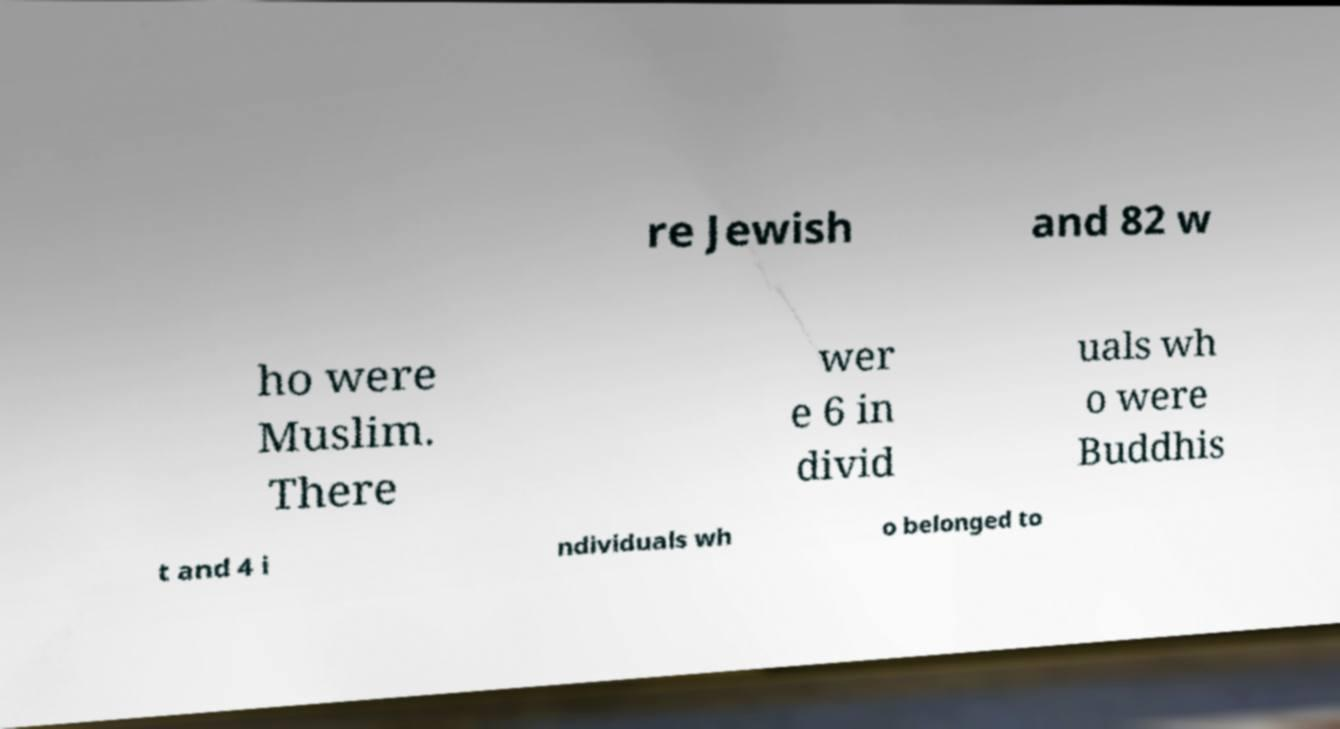Please read and relay the text visible in this image. What does it say? re Jewish and 82 w ho were Muslim. There wer e 6 in divid uals wh o were Buddhis t and 4 i ndividuals wh o belonged to 